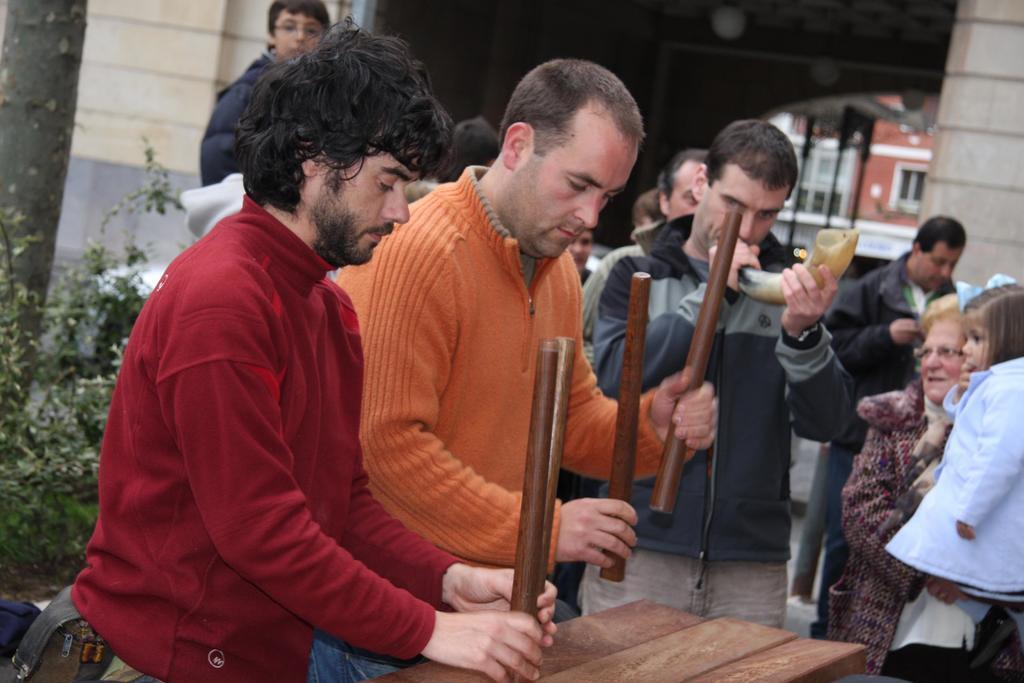Please provide a concise description of this image. In the picture I can see some people and there are holding an objects, behind we can see some buildings, plants. 